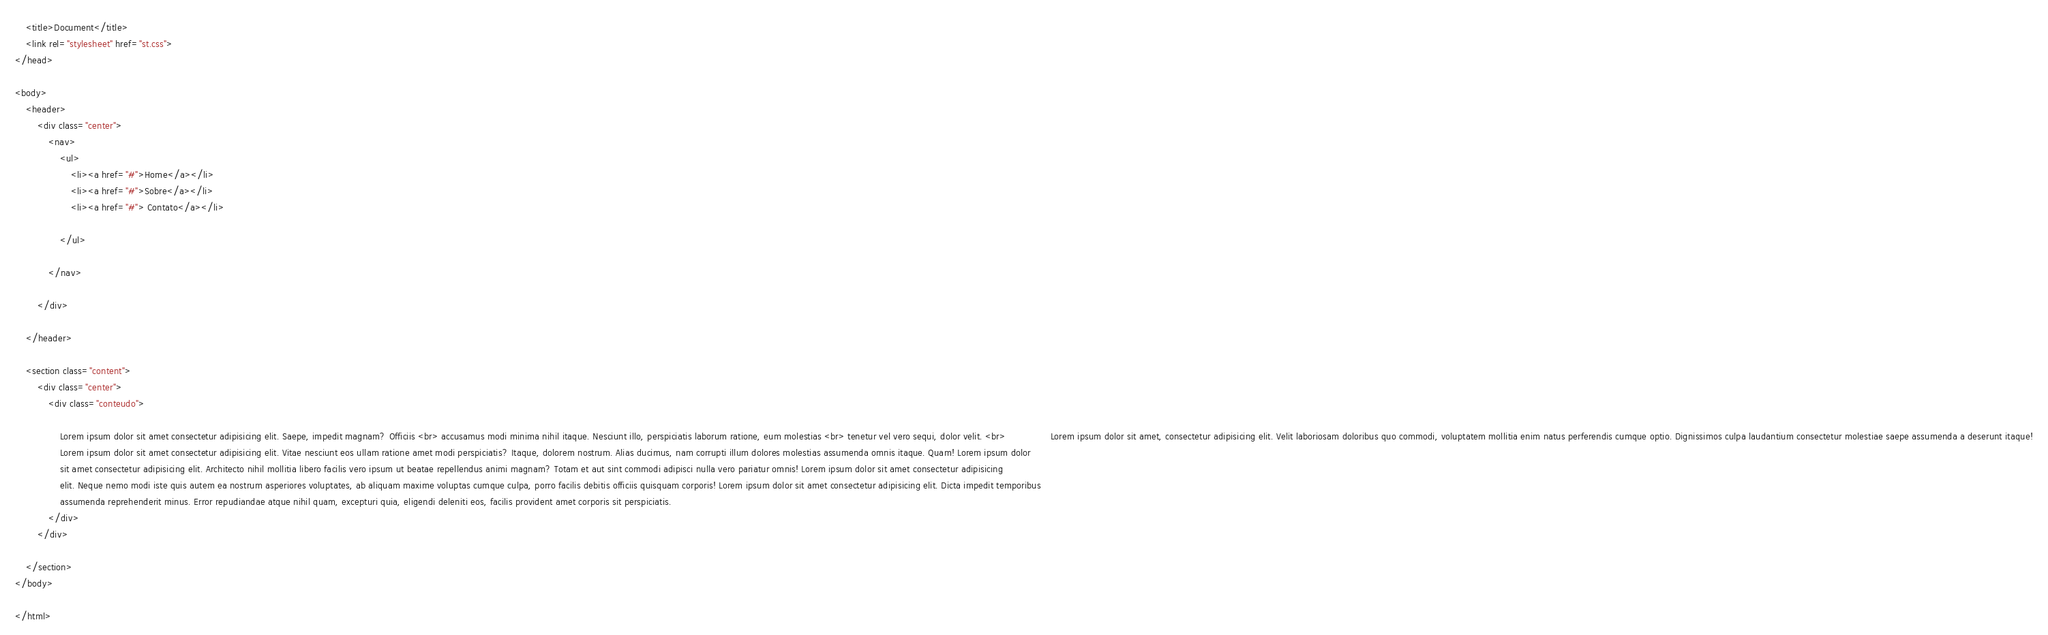<code> <loc_0><loc_0><loc_500><loc_500><_HTML_>    <title>Document</title>
    <link rel="stylesheet" href="st.css">
</head>

<body>
    <header>
        <div class="center">
            <nav>
                <ul>
                    <li><a href="#">Home</a></li>
                    <li><a href="#">Sobre</a></li>
                    <li><a href="#"> Contato</a></li>

                </ul>

            </nav>

        </div>

    </header>

    <section class="content">
        <div class="center">
            <div class="conteudo">

                Lorem ipsum dolor sit amet consectetur adipisicing elit. Saepe, impedit magnam? Officiis <br> accusamus modi minima nihil itaque. Nesciunt illo, perspiciatis laborum ratione, eum molestias <br> tenetur vel vero sequi, dolor velit. <br>                Lorem ipsum dolor sit amet, consectetur adipisicing elit. Velit laboriosam doloribus quo commodi, voluptatem mollitia enim natus perferendis cumque optio. Dignissimos culpa laudantium consectetur molestiae saepe assumenda a deserunt itaque!
                Lorem ipsum dolor sit amet consectetur adipisicing elit. Vitae nesciunt eos ullam ratione amet modi perspiciatis? Itaque, dolorem nostrum. Alias ducimus, nam corrupti illum dolores molestias assumenda omnis itaque. Quam! Lorem ipsum dolor
                sit amet consectetur adipisicing elit. Architecto nihil mollitia libero facilis vero ipsum ut beatae repellendus animi magnam? Totam et aut sint commodi adipisci nulla vero pariatur omnis! Lorem ipsum dolor sit amet consectetur adipisicing
                elit. Neque nemo modi iste quis autem ea nostrum asperiores voluptates, ab aliquam maxime voluptas cumque culpa, porro facilis debitis officiis quisquam corporis! Lorem ipsum dolor sit amet consectetur adipisicing elit. Dicta impedit temporibus
                assumenda reprehenderit minus. Error repudiandae atque nihil quam, excepturi quia, eligendi deleniti eos, facilis provident amet corporis sit perspiciatis.
            </div>
        </div>

    </section>
</body>

</html></code> 